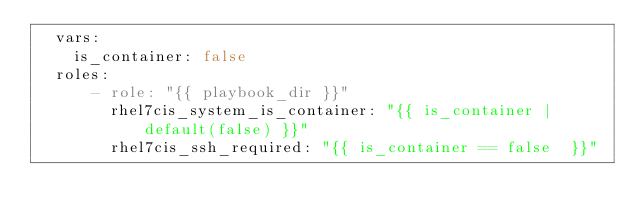Convert code to text. <code><loc_0><loc_0><loc_500><loc_500><_YAML_>  vars:
    is_container: false
  roles:
      - role: "{{ playbook_dir }}"
        rhel7cis_system_is_container: "{{ is_container | default(false) }}"
        rhel7cis_ssh_required: "{{ is_container == false  }}"
</code> 